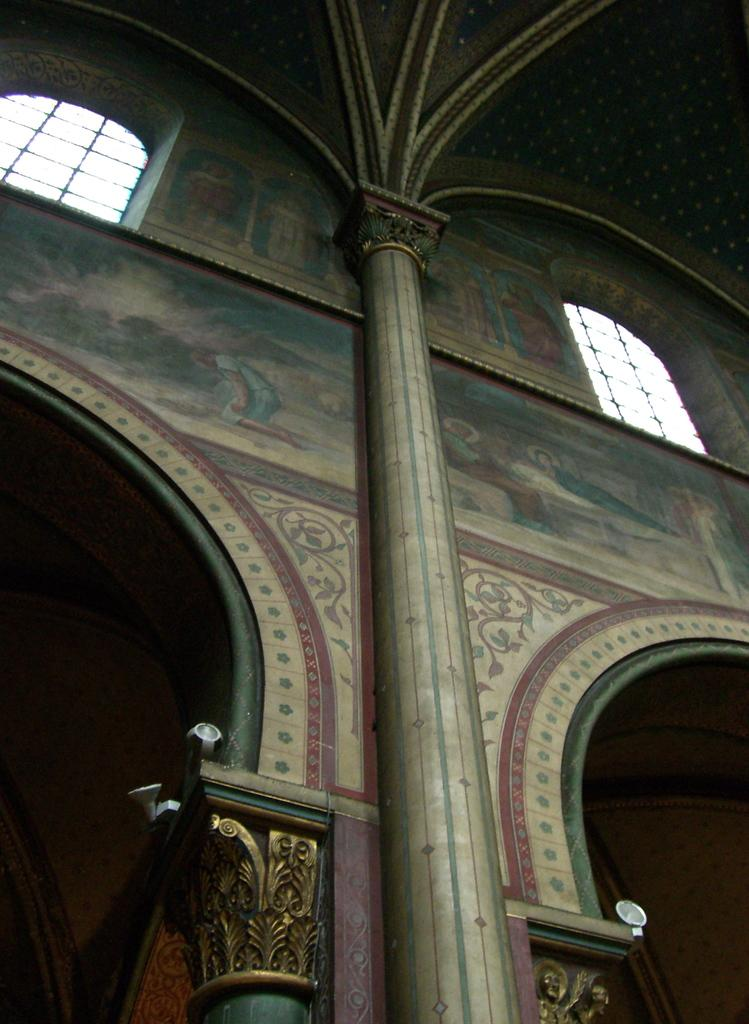What is the main structure visible in the image? There is a building in the image. What can be seen on the walls of the building? There are paintings on the walls of the building. How many fruits are hanging from the paintings in the image? There are no fruits present in the image, as it only features a building with paintings on the walls. 